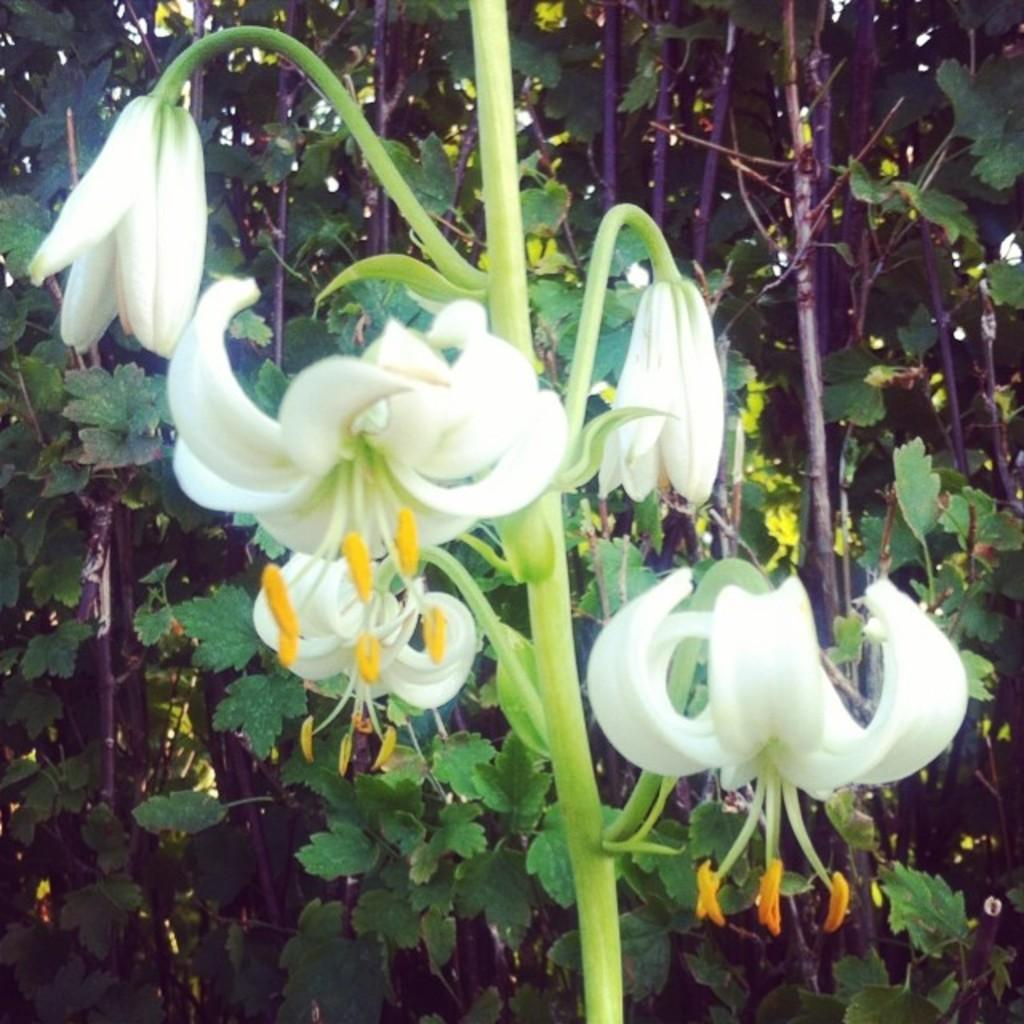What type of plant is visible in the image? There are flowers on stems of a plant in the image. Can you describe the background of the image? There is a group of plants in the background of the image. What type of cable can be seen connecting the flowers in the image? There is no cable present in the image; it features a plant with flowers on its stems and a group of plants in the plants in the background. 